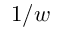<formula> <loc_0><loc_0><loc_500><loc_500>1 / w</formula> 